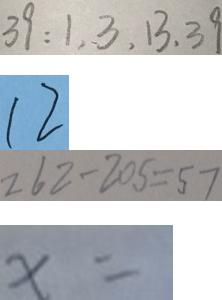<formula> <loc_0><loc_0><loc_500><loc_500>3 9 : 1 , 3 , 1 3 , 3 9 
 1 2 
 2 6 2 - 2 0 5 = 5 7 
 x =</formula> 